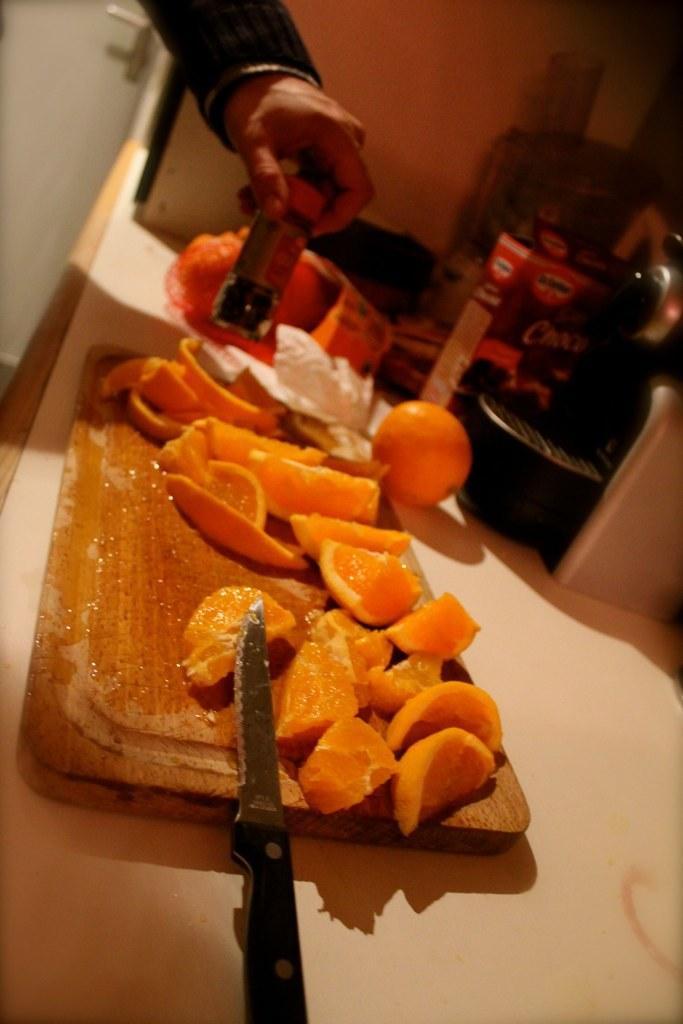Please provide a concise description of this image. In this image in the center there are fruits. In the front there is a knife and in the background there is a person holding a bottle and the right side there is a box and there is an object which is black in colour. 